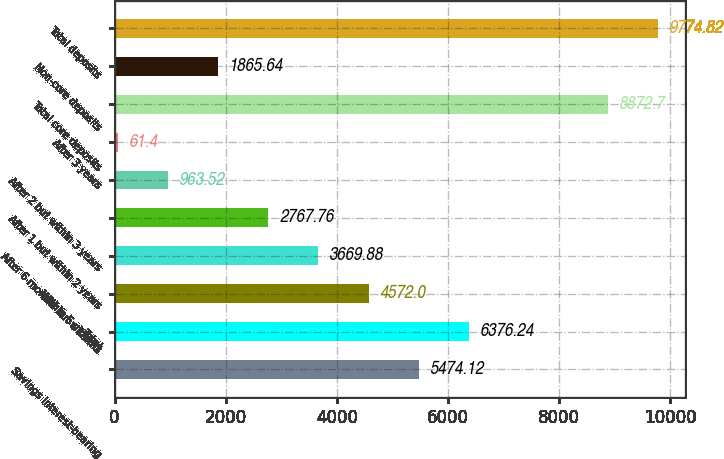Convert chart. <chart><loc_0><loc_0><loc_500><loc_500><bar_chart><fcel>Savings interest-bearing<fcel>Total<fcel>Within 6 months<fcel>After 6 months but within 1<fcel>After 1 but within 2 years<fcel>After 2 but within 3 years<fcel>After 3 years<fcel>Total core deposits<fcel>Non-core deposits<fcel>Total deposits<nl><fcel>5474.12<fcel>6376.24<fcel>4572<fcel>3669.88<fcel>2767.76<fcel>963.52<fcel>61.4<fcel>8872.7<fcel>1865.64<fcel>9774.82<nl></chart> 